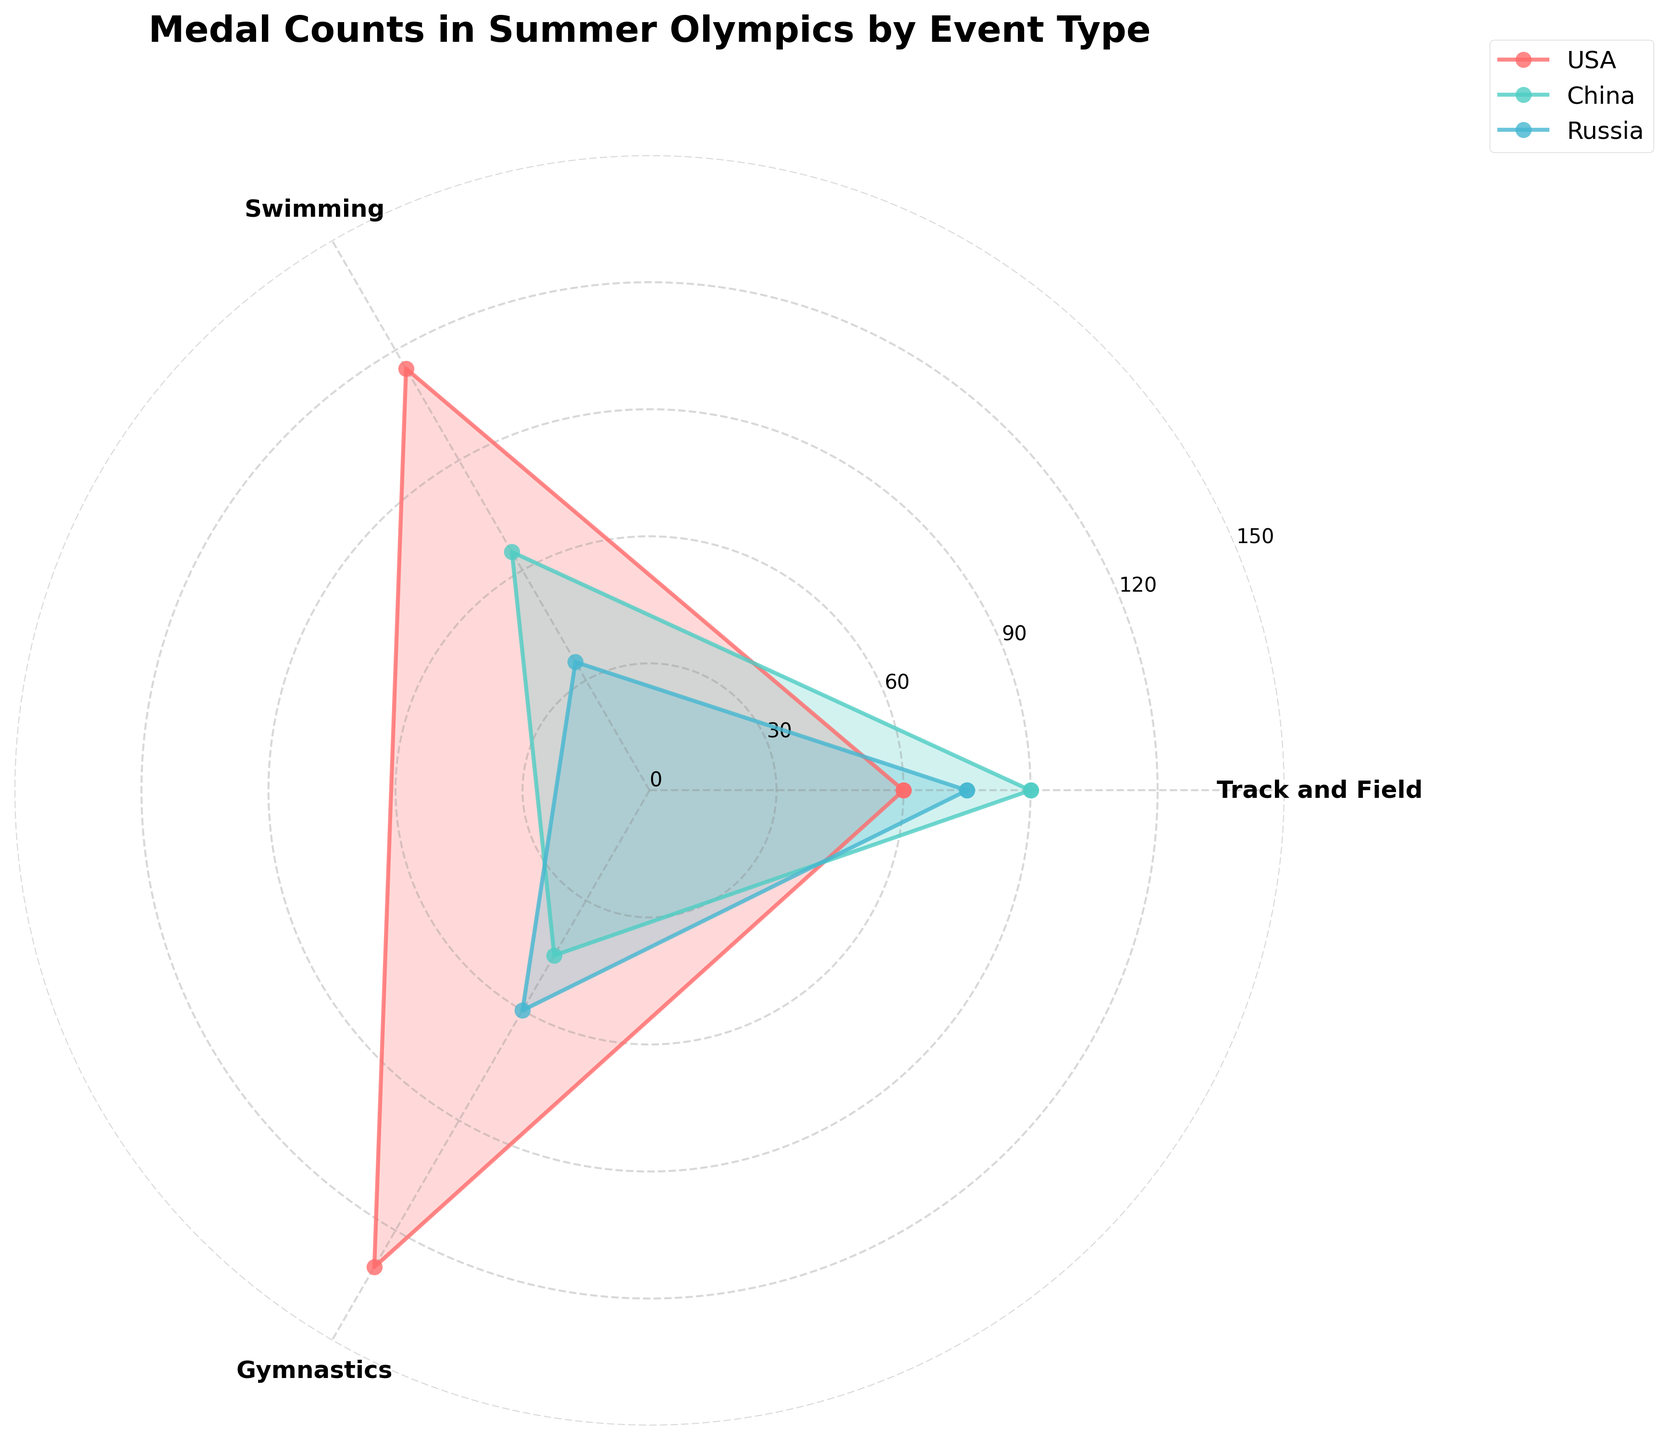How many event types are shown in the figure? The figure shows Track and Field, Swimming, and Gymnastics, making a total of three event types.
Answer: 3 Which country has the highest total medal count in Swimming? The USA has 55 gold, 35 silver, and 25 bronze medals in Swimming. Adding them gives a total of 115, which is higher than other countries.
Answer: USA What is the sum of gold medals won by Russia in Track and Field and Gymnastics? In the figure, Russia has 25 gold medals in Track and Field and 30 gold medals in Gymnastics. Adding them gives 25 + 30 = 55.
Answer: 55 Who has more gold medals in Gymnastics, China or the USA? China has 40 gold medals in Gymnastics, while the USA has 25 gold medals in the same event, hence China has more.
Answer: China What is the difference in the total medal count between Russia and China in Swimming? Adding up Russia's Swimming medals gives 15 gold + 10 silver + 10 bronze = 35. Adding up China's Swimming medals gives 30 gold + 20 silver + 15 bronze = 65. The difference is 65 - 35 = 30.
Answer: 30 Which event type shows the smallest difference in total medals between USA and Russia? Summing up each event type for both countries:
- Track and Field: USA has 60+40+30=130; Russia has 25+20+15=60; Difference = 70
- Swimming: USA has 55+35+25=115; Russia has 15+10+10=35; Difference = 80
- Gymnastics: USA has 25+20+15=60; Russia has 30+25+20=75; Difference = 15
Gymnastics has the smallest difference, 15 medals.
Answer: Gymnastics Which country has the lowest total count of silver medals in Swimming? Looking at the figure, USA has 35, China has 20, and Russia has 10 silver medals in Swimming. Therefore, Russia has the lowest count.
Answer: Russia How does the total medal count of China in Gymnastics compare to the total count of Russia in Swimming? China has 40+30+20=90 in Gymnastics, and Russia has 15+10+10=35 in Swimming. Hence, China's total is higher.
Answer: China Which event type has the highest number of gold medals for the USA? The USA has 60 gold medals in Track and Field, 55 in Swimming, and 25 in Gymnastics. Hence, Track and Field has the highest number.
Answer: Track and Field 